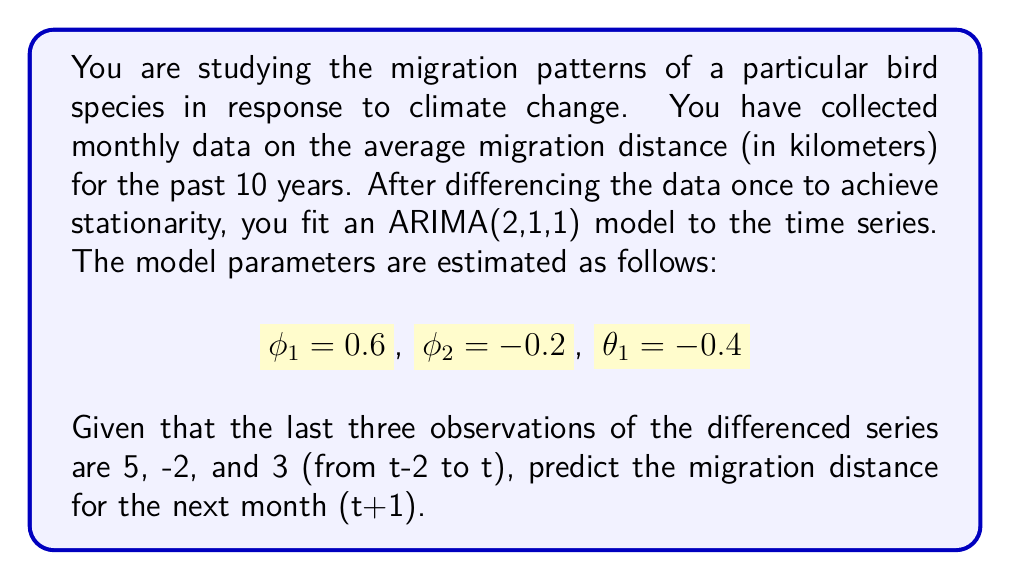What is the answer to this math problem? To solve this problem, we need to use the ARIMA(2,1,1) model equation and the given parameters. The general form of an ARIMA(2,1,1) model for the differenced series is:

$$(1 - \phi_1B - \phi_2B^2)(1-B)y_t = (1 - \theta_1B)\varepsilon_t$$

Where $B$ is the backshift operator, $y_t$ is the original series, and $\varepsilon_t$ is the error term.

For forecasting, we can rewrite this as:

$$\hat{y}_{t+1} = y_t + \phi_1(y_t - y_{t-1}) + \phi_2(y_{t-1} - y_{t-2}) - \theta_1\varepsilon_t$$

Where $\hat{y}_{t+1}$ is the forecast for the next period.

Given:
$\phi_1 = 0.6$, $\phi_2 = -0.2$, $\theta_1 = -0.4$

The last three observations of the differenced series are:
$y_t - y_{t-1} = 3$
$y_{t-1} - y_{t-2} = -2$
$y_{t-2} - y_{t-3} = 5$

We need to forecast the next value of the differenced series:

$$\hat{y}_{t+1} - y_t = \phi_1(y_t - y_{t-1}) + \phi_2(y_{t-1} - y_{t-2}) - \theta_1\varepsilon_t$$

The error term $\varepsilon_t$ is typically assumed to be zero for forecasting purposes. Substituting the values:

$$\hat{y}_{t+1} - y_t = 0.6(3) + (-0.2)(-2) - (-0.4)(0)$$
$$\hat{y}_{t+1} - y_t = 1.8 + 0.4 = 2.2$$

Therefore, the forecast for the differenced series at t+1 is 2.2 km.
Answer: The predicted change in migration distance for the next month (t+1) is 2.2 km. 